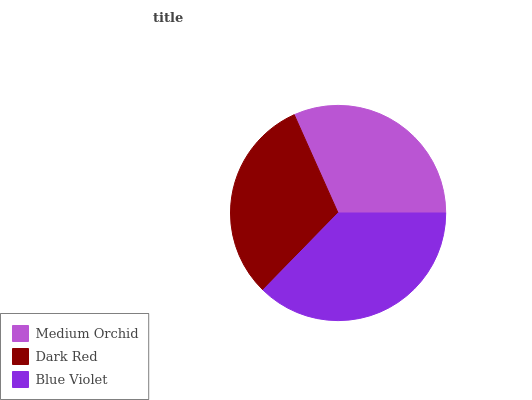Is Dark Red the minimum?
Answer yes or no. Yes. Is Blue Violet the maximum?
Answer yes or no. Yes. Is Blue Violet the minimum?
Answer yes or no. No. Is Dark Red the maximum?
Answer yes or no. No. Is Blue Violet greater than Dark Red?
Answer yes or no. Yes. Is Dark Red less than Blue Violet?
Answer yes or no. Yes. Is Dark Red greater than Blue Violet?
Answer yes or no. No. Is Blue Violet less than Dark Red?
Answer yes or no. No. Is Medium Orchid the high median?
Answer yes or no. Yes. Is Medium Orchid the low median?
Answer yes or no. Yes. Is Dark Red the high median?
Answer yes or no. No. Is Dark Red the low median?
Answer yes or no. No. 